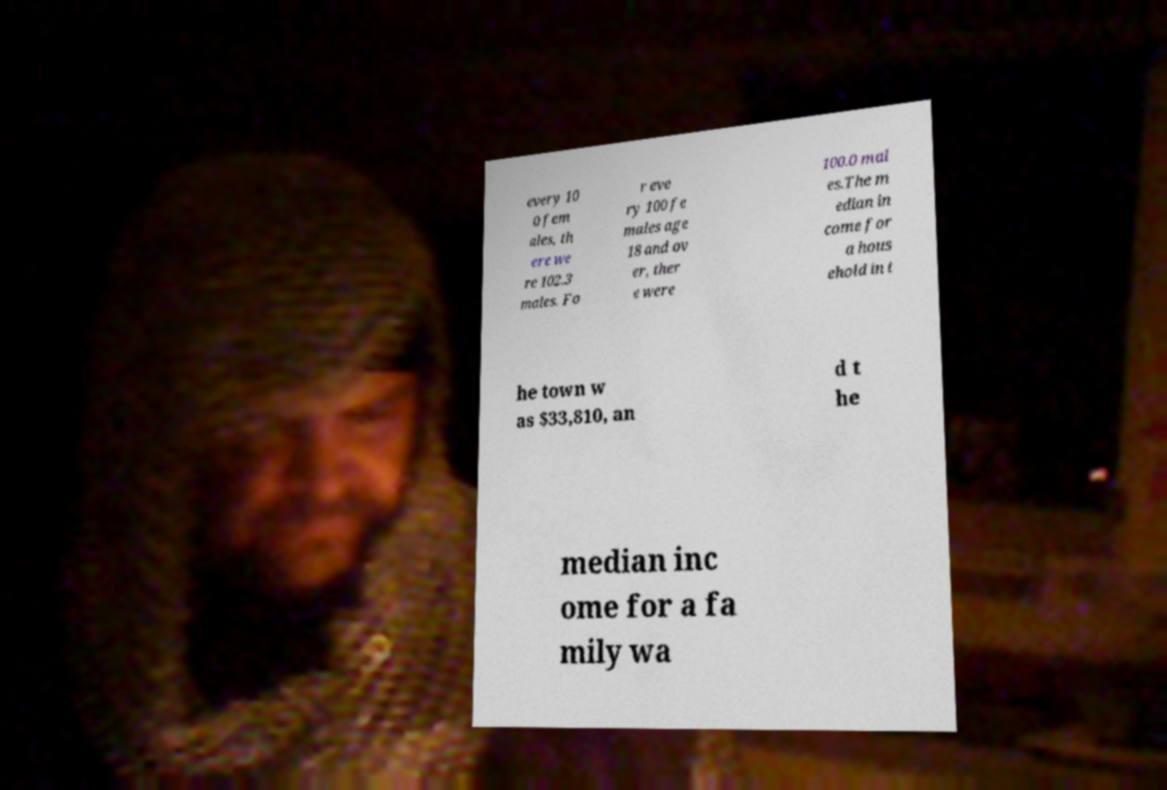Please identify and transcribe the text found in this image. every 10 0 fem ales, th ere we re 102.3 males. Fo r eve ry 100 fe males age 18 and ov er, ther e were 100.0 mal es.The m edian in come for a hous ehold in t he town w as $33,810, an d t he median inc ome for a fa mily wa 